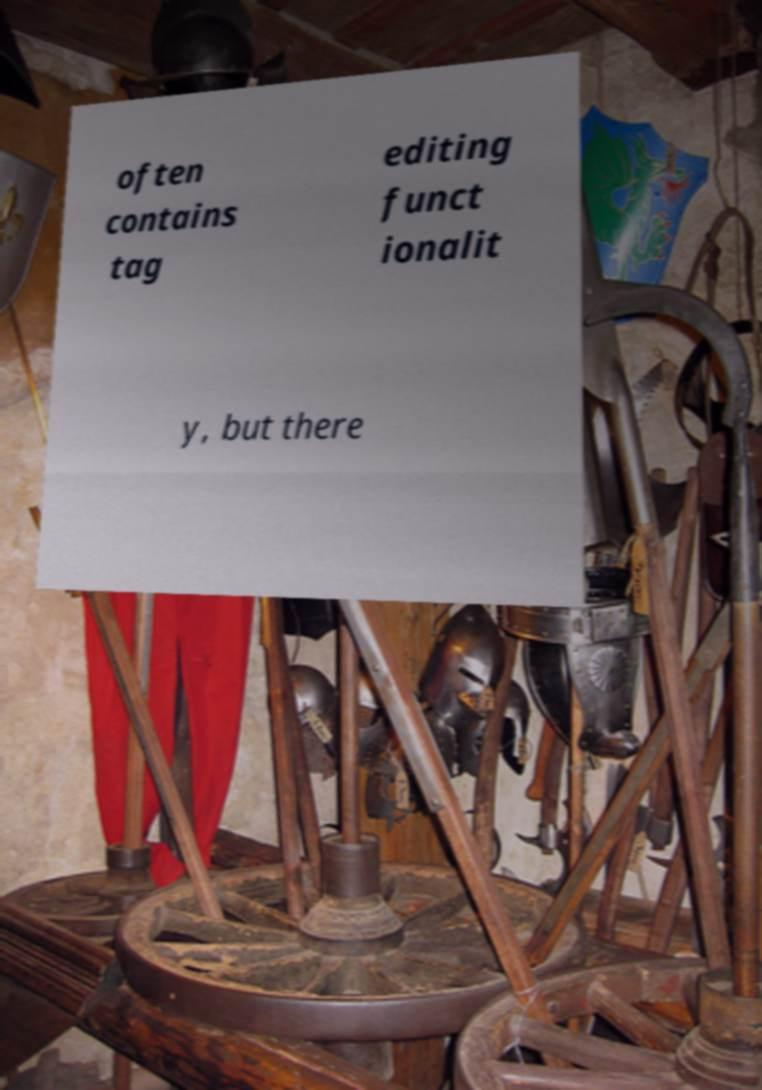What messages or text are displayed in this image? I need them in a readable, typed format. often contains tag editing funct ionalit y, but there 